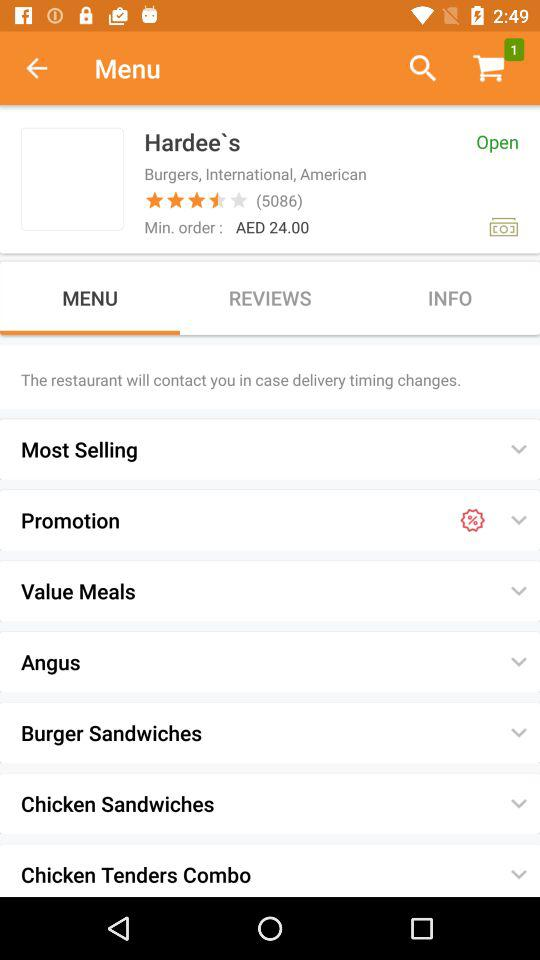How many people give reviews of Hardee's restaurant? The number of people who gave reviews is 5086. 